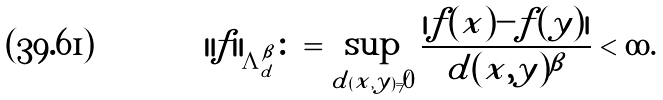<formula> <loc_0><loc_0><loc_500><loc_500>\| f \| _ { \Lambda ^ { \beta } _ { d } } \colon = \sup _ { d ( x , y ) \ne 0 } \frac { | f ( x ) - f ( y ) | } { d ( x , y ) ^ { \beta } } < \infty .</formula> 